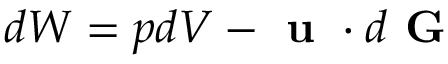Convert formula to latex. <formula><loc_0><loc_0><loc_500><loc_500>d W = p d V - u \cdot d G</formula> 